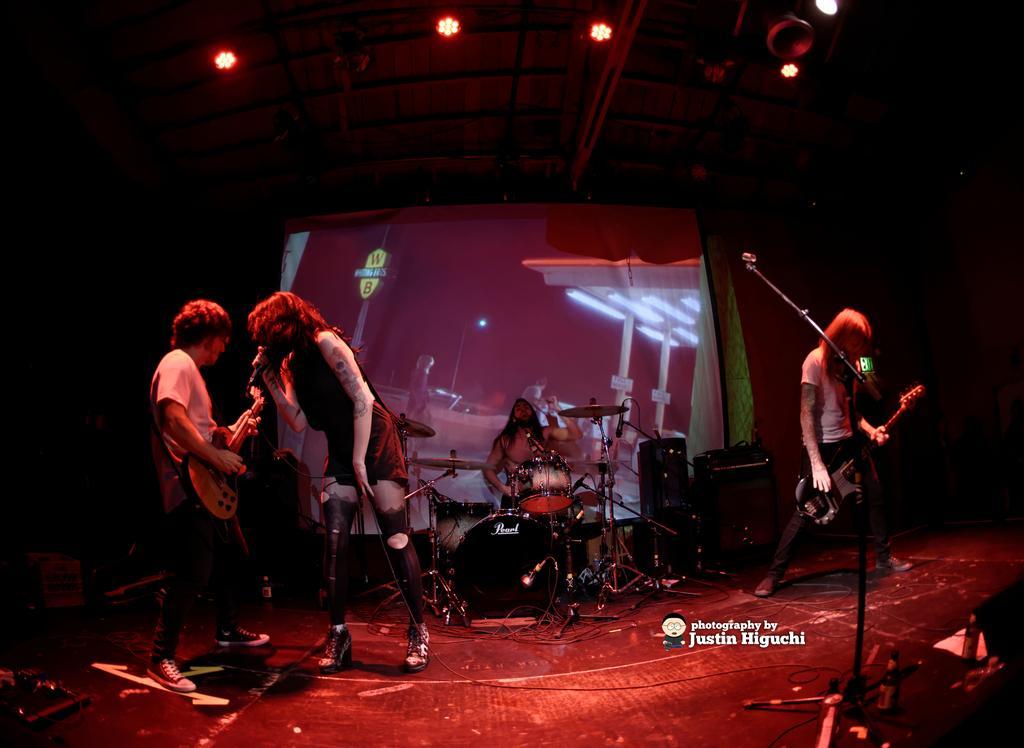Describe this image in one or two sentences. In picture there is a stage in which two persons are playing guitar and one person is singing in a microphone and another person is playing drums there are sound systems near the person there lights near to the roof there is an LED screen back of the person playing drums. 